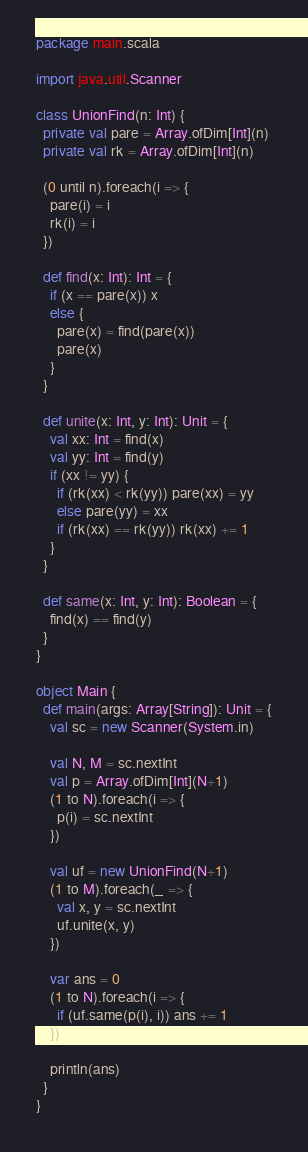<code> <loc_0><loc_0><loc_500><loc_500><_Scala_>package main.scala

import java.util.Scanner

class UnionFind(n: Int) {
  private val pare = Array.ofDim[Int](n)
  private val rk = Array.ofDim[Int](n)

  (0 until n).foreach(i => {
    pare(i) = i
    rk(i) = i
  })

  def find(x: Int): Int = {
    if (x == pare(x)) x
    else {
      pare(x) = find(pare(x))
      pare(x)
    }
  }

  def unite(x: Int, y: Int): Unit = {
    val xx: Int = find(x)
    val yy: Int = find(y)
    if (xx != yy) {
      if (rk(xx) < rk(yy)) pare(xx) = yy
      else pare(yy) = xx
      if (rk(xx) == rk(yy)) rk(xx) += 1
    }
  }

  def same(x: Int, y: Int): Boolean = {
    find(x) == find(y)
  }
}

object Main {
  def main(args: Array[String]): Unit = {
    val sc = new Scanner(System.in)

    val N, M = sc.nextInt
    val p = Array.ofDim[Int](N+1)
    (1 to N).foreach(i => {
      p(i) = sc.nextInt
    })

    val uf = new UnionFind(N+1)
    (1 to M).foreach(_ => {
      val x, y = sc.nextInt
      uf.unite(x, y)
    })

    var ans = 0
    (1 to N).foreach(i => {
      if (uf.same(p(i), i)) ans += 1
    })

    println(ans)
  }
}</code> 